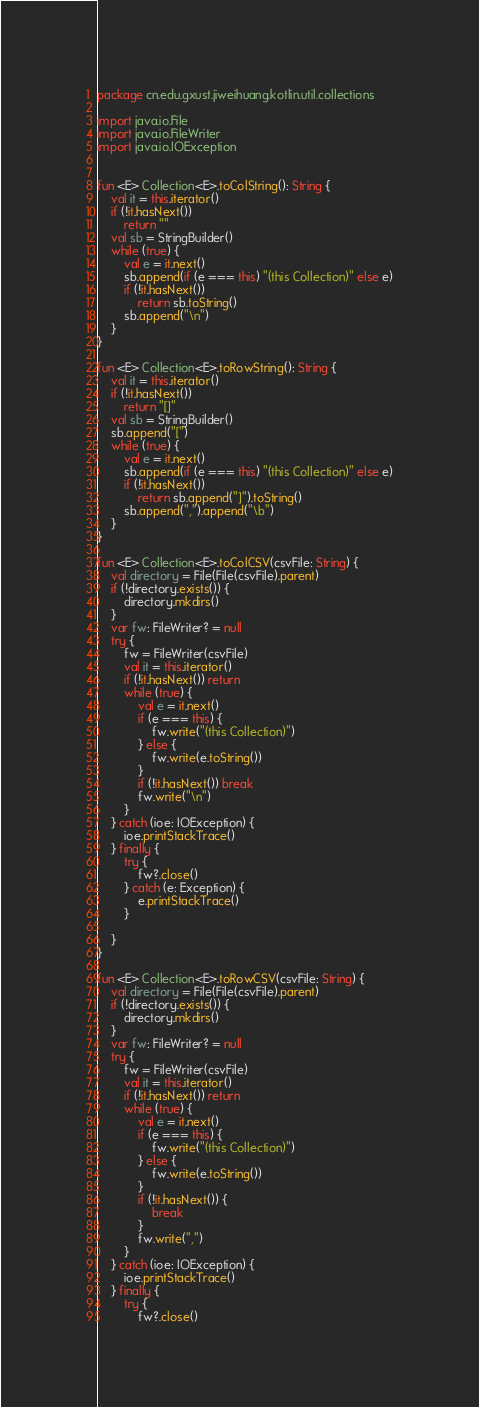<code> <loc_0><loc_0><loc_500><loc_500><_Kotlin_>package cn.edu.gxust.jiweihuang.kotlin.util.collections

import java.io.File
import java.io.FileWriter
import java.io.IOException


fun <E> Collection<E>.toColString(): String {
    val it = this.iterator()
    if (!it.hasNext())
        return ""
    val sb = StringBuilder()
    while (true) {
        val e = it.next()
        sb.append(if (e === this) "(this Collection)" else e)
        if (!it.hasNext())
            return sb.toString()
        sb.append("\n")
    }
}

fun <E> Collection<E>.toRowString(): String {
    val it = this.iterator()
    if (!it.hasNext())
        return "[]"
    val sb = StringBuilder()
    sb.append("[")
    while (true) {
        val e = it.next()
        sb.append(if (e === this) "(this Collection)" else e)
        if (!it.hasNext())
            return sb.append("]").toString()
        sb.append(",").append("\b")
    }
}

fun <E> Collection<E>.toColCSV(csvFile: String) {
    val directory = File(File(csvFile).parent)
    if (!directory.exists()) {
        directory.mkdirs()
    }
    var fw: FileWriter? = null
    try {
        fw = FileWriter(csvFile)
        val it = this.iterator()
        if (!it.hasNext()) return
        while (true) {
            val e = it.next()
            if (e === this) {
                fw.write("(this Collection)")
            } else {
                fw.write(e.toString())
            }
            if (!it.hasNext()) break
            fw.write("\n")
        }
    } catch (ioe: IOException) {
        ioe.printStackTrace()
    } finally {
        try {
            fw?.close()
        } catch (e: Exception) {
            e.printStackTrace()
        }

    }
}

fun <E> Collection<E>.toRowCSV(csvFile: String) {
    val directory = File(File(csvFile).parent)
    if (!directory.exists()) {
        directory.mkdirs()
    }
    var fw: FileWriter? = null
    try {
        fw = FileWriter(csvFile)
        val it = this.iterator()
        if (!it.hasNext()) return
        while (true) {
            val e = it.next()
            if (e === this) {
                fw.write("(this Collection)")
            } else {
                fw.write(e.toString())
            }
            if (!it.hasNext()) {
                break
            }
            fw.write(",")
        }
    } catch (ioe: IOException) {
        ioe.printStackTrace()
    } finally {
        try {
            fw?.close()</code> 